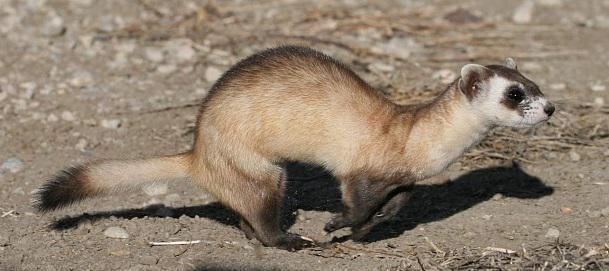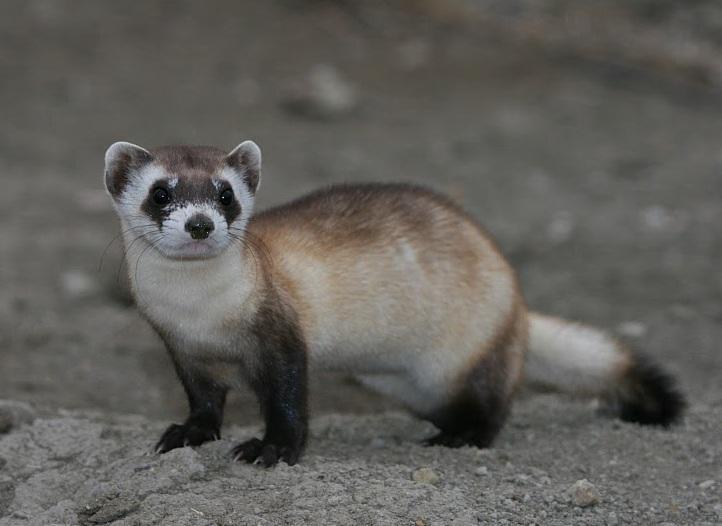The first image is the image on the left, the second image is the image on the right. Given the left and right images, does the statement "An image contains a prairie dog coming out of a hole." hold true? Answer yes or no. No. The first image is the image on the left, the second image is the image on the right. Assess this claim about the two images: "Each image contains one ferret, and no ferrets are emerging from a hole in the ground.". Correct or not? Answer yes or no. Yes. 